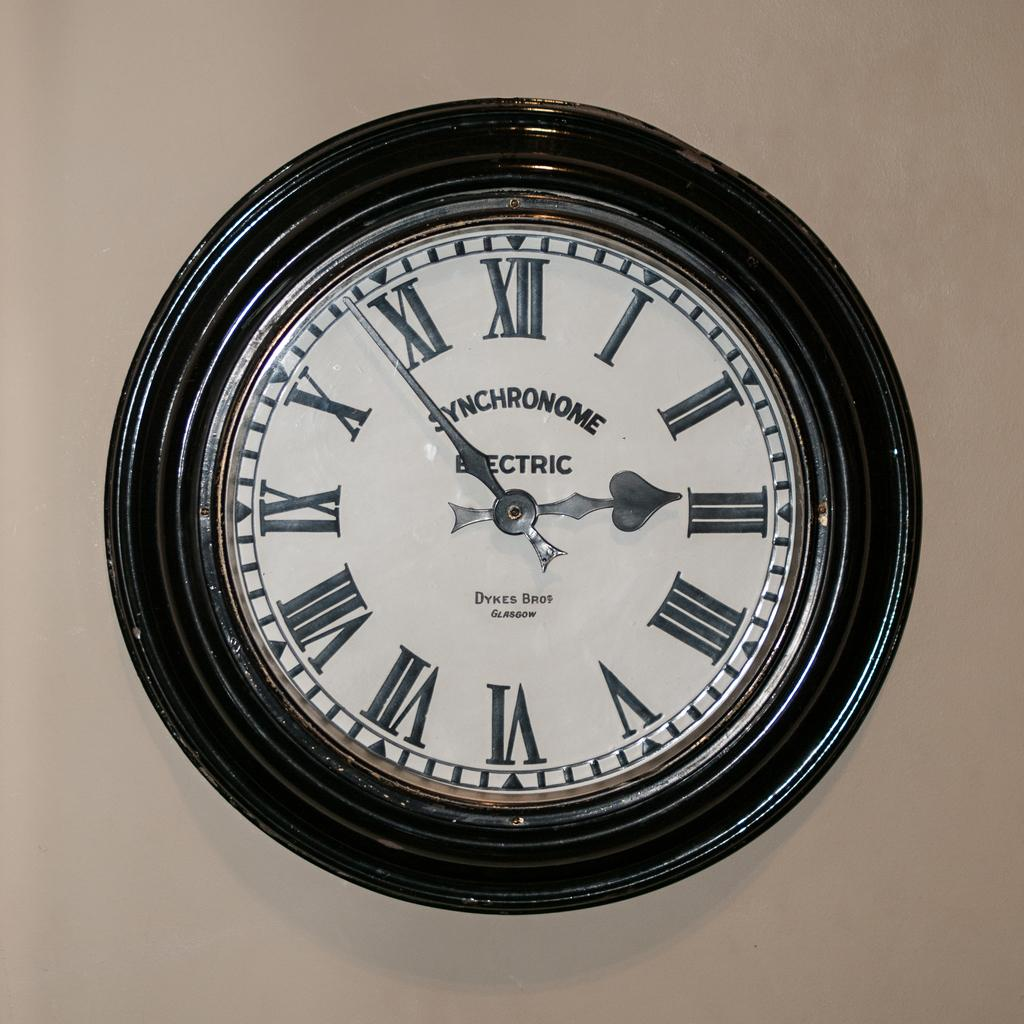<image>
Offer a succinct explanation of the picture presented. A wall clock that is made by Dykes Bros Glasgow. 